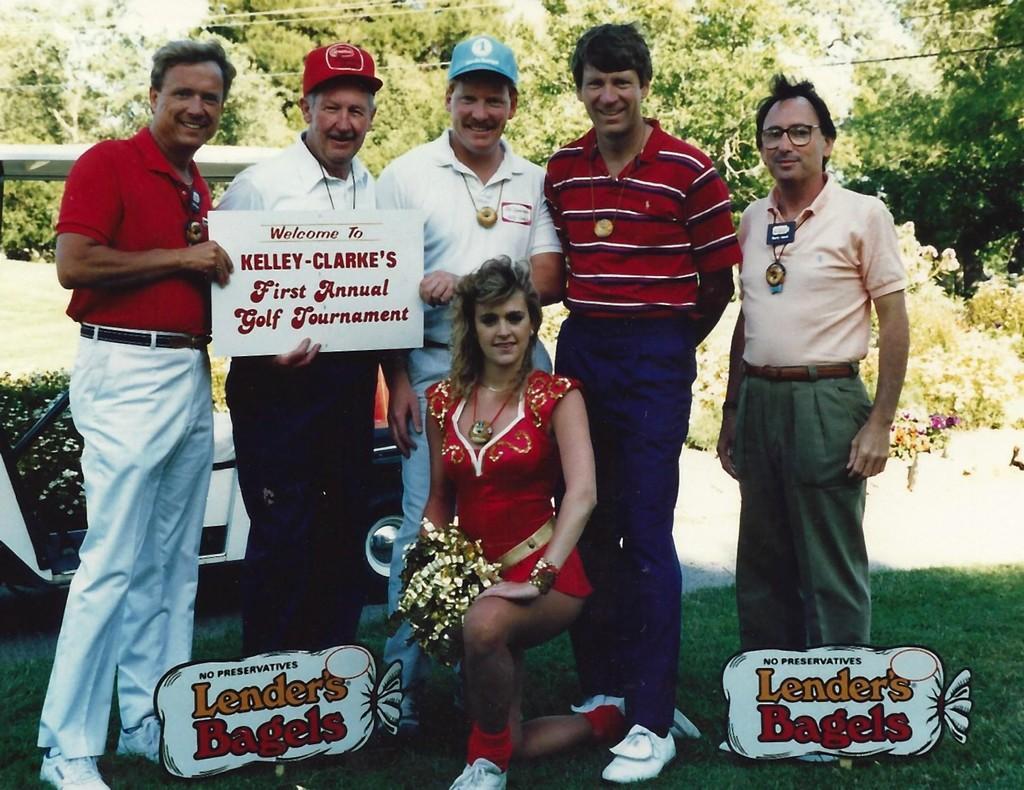Can you describe this image briefly? Here we can see few persons and they are holding a board with their hands. This is grass and there are plants. Here we can see a vehicle. In the background there are trees. 